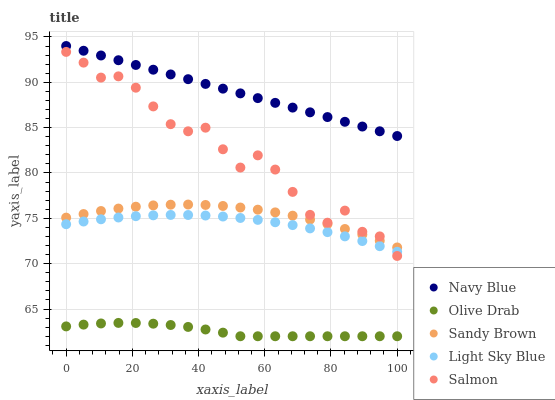Does Olive Drab have the minimum area under the curve?
Answer yes or no. Yes. Does Navy Blue have the maximum area under the curve?
Answer yes or no. Yes. Does Light Sky Blue have the minimum area under the curve?
Answer yes or no. No. Does Light Sky Blue have the maximum area under the curve?
Answer yes or no. No. Is Navy Blue the smoothest?
Answer yes or no. Yes. Is Salmon the roughest?
Answer yes or no. Yes. Is Light Sky Blue the smoothest?
Answer yes or no. No. Is Light Sky Blue the roughest?
Answer yes or no. No. Does Olive Drab have the lowest value?
Answer yes or no. Yes. Does Light Sky Blue have the lowest value?
Answer yes or no. No. Does Navy Blue have the highest value?
Answer yes or no. Yes. Does Light Sky Blue have the highest value?
Answer yes or no. No. Is Olive Drab less than Navy Blue?
Answer yes or no. Yes. Is Sandy Brown greater than Olive Drab?
Answer yes or no. Yes. Does Sandy Brown intersect Salmon?
Answer yes or no. Yes. Is Sandy Brown less than Salmon?
Answer yes or no. No. Is Sandy Brown greater than Salmon?
Answer yes or no. No. Does Olive Drab intersect Navy Blue?
Answer yes or no. No. 